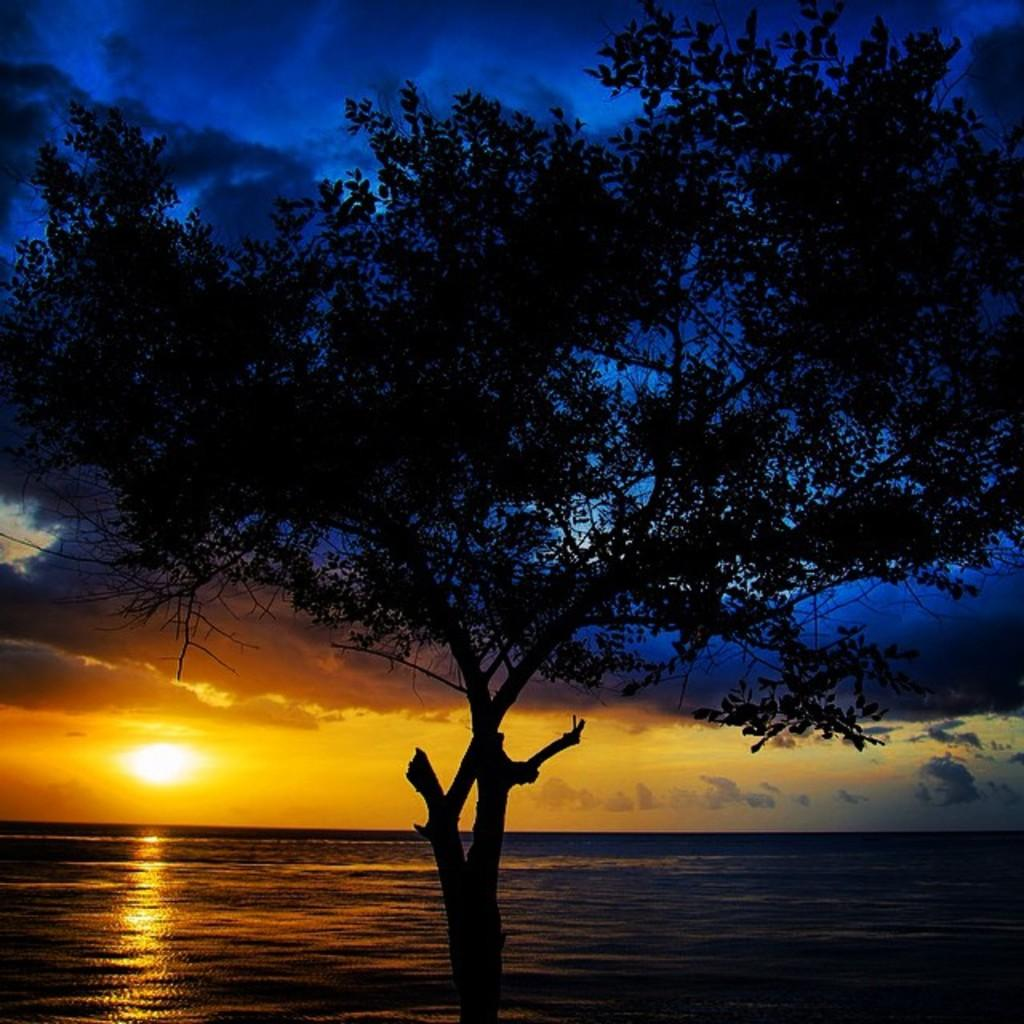What is the main subject in the center of the image? There is a tree in the center of the image. What can be seen at the bottom of the image? There is a river at the bottom of the image. What is visible in the background of the image? The sky is visible in the background of the image. How many sheep are grazing near the river in the image? There are no sheep present in the image. What type of utensil is used to eat the tree in the image? The tree is not meant to be eaten, and there are no utensils present in the image. 